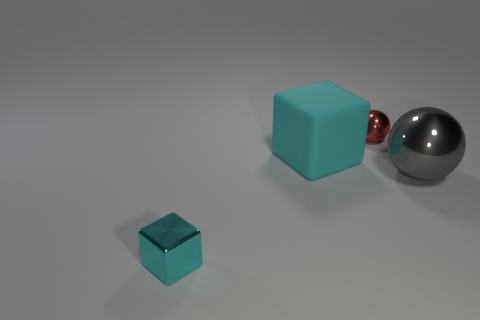What is the size of the cyan metallic object that is on the left side of the small thing that is right of the tiny shiny block?
Your answer should be very brief. Small. What number of objects are yellow matte balls or big rubber cubes?
Your response must be concise. 1. Is the shape of the small red shiny object the same as the large gray shiny thing?
Your answer should be very brief. Yes. Is there a red sphere made of the same material as the gray object?
Ensure brevity in your answer.  Yes. There is a tiny shiny thing on the right side of the tiny cyan metallic thing; are there any cyan metal cubes right of it?
Your response must be concise. No. There is a metal sphere that is in front of the cyan matte thing; does it have the same size as the big matte thing?
Provide a succinct answer. Yes. How big is the red shiny thing?
Provide a short and direct response. Small. Is there a cube that has the same color as the big metallic thing?
Make the answer very short. No. What number of big things are metal balls or cyan blocks?
Offer a terse response. 2. How big is the object that is in front of the big rubber object and to the left of the small red metallic object?
Your answer should be very brief. Small. 